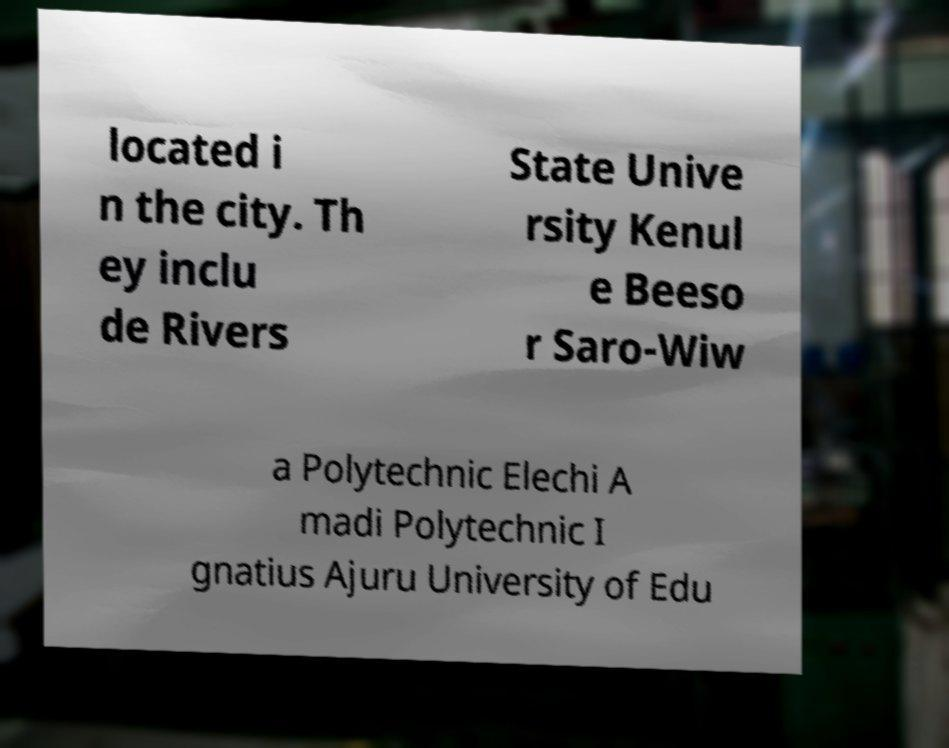Could you assist in decoding the text presented in this image and type it out clearly? located i n the city. Th ey inclu de Rivers State Unive rsity Kenul e Beeso r Saro-Wiw a Polytechnic Elechi A madi Polytechnic I gnatius Ajuru University of Edu 